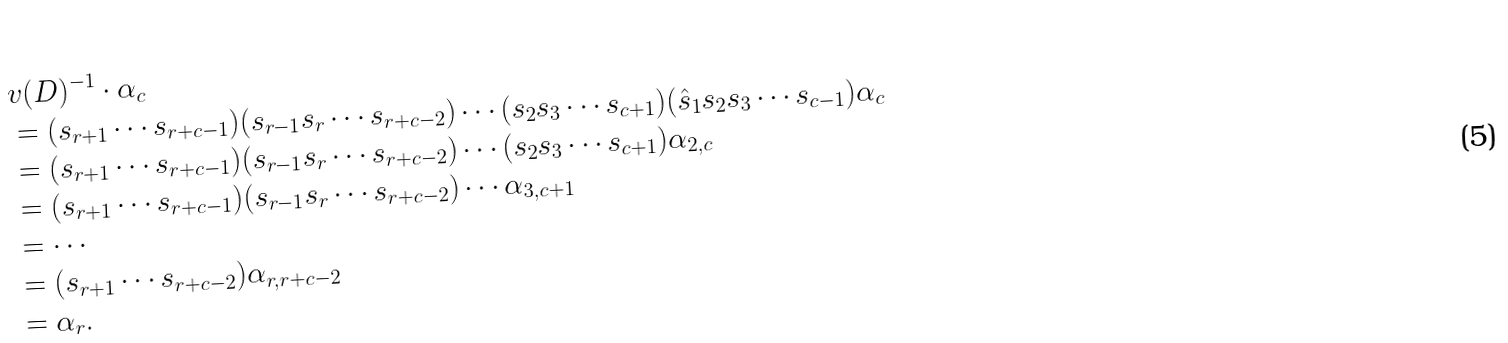<formula> <loc_0><loc_0><loc_500><loc_500>& v ( D ) ^ { - 1 } \cdot \alpha _ { c } \\ & = ( s _ { r + 1 } \cdots s _ { r + c - 1 } ) ( s _ { r - 1 } s _ { r } \cdots s _ { r + c - 2 } ) \cdots ( s _ { 2 } s _ { 3 } \cdots s _ { c + 1 } ) ( \hat { s } _ { 1 } s _ { 2 } s _ { 3 } \cdots s _ { c - 1 } ) \alpha _ { c } \\ & = ( s _ { r + 1 } \cdots s _ { r + c - 1 } ) ( s _ { r - 1 } s _ { r } \cdots s _ { r + c - 2 } ) \cdots ( s _ { 2 } s _ { 3 } \cdots s _ { c + 1 } ) \alpha _ { 2 , c } \\ & = ( s _ { r + 1 } \cdots s _ { r + c - 1 } ) ( s _ { r - 1 } s _ { r } \cdots s _ { r + c - 2 } ) \cdots \alpha _ { 3 , c + 1 } \\ & = \cdots \\ & = ( s _ { r + 1 } \cdots s _ { r + c - 2 } ) \alpha _ { r , r + c - 2 } \\ & = \alpha _ { r } .</formula> 